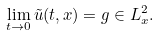<formula> <loc_0><loc_0><loc_500><loc_500>\lim _ { t \rightarrow 0 } \tilde { u } ( t , x ) = g \in L ^ { 2 } _ { x } .</formula> 